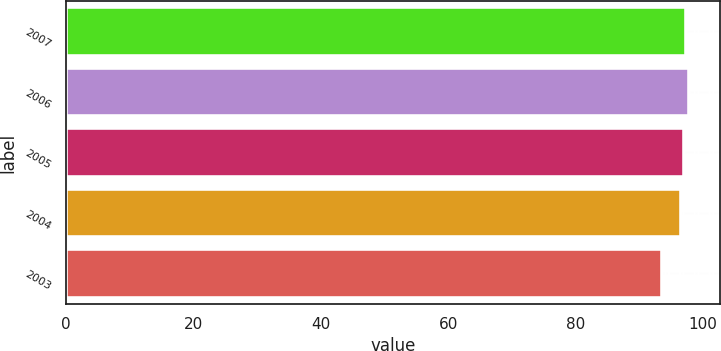Convert chart. <chart><loc_0><loc_0><loc_500><loc_500><bar_chart><fcel>2007<fcel>2006<fcel>2005<fcel>2004<fcel>2003<nl><fcel>97.38<fcel>97.76<fcel>97<fcel>96.5<fcel>93.6<nl></chart> 